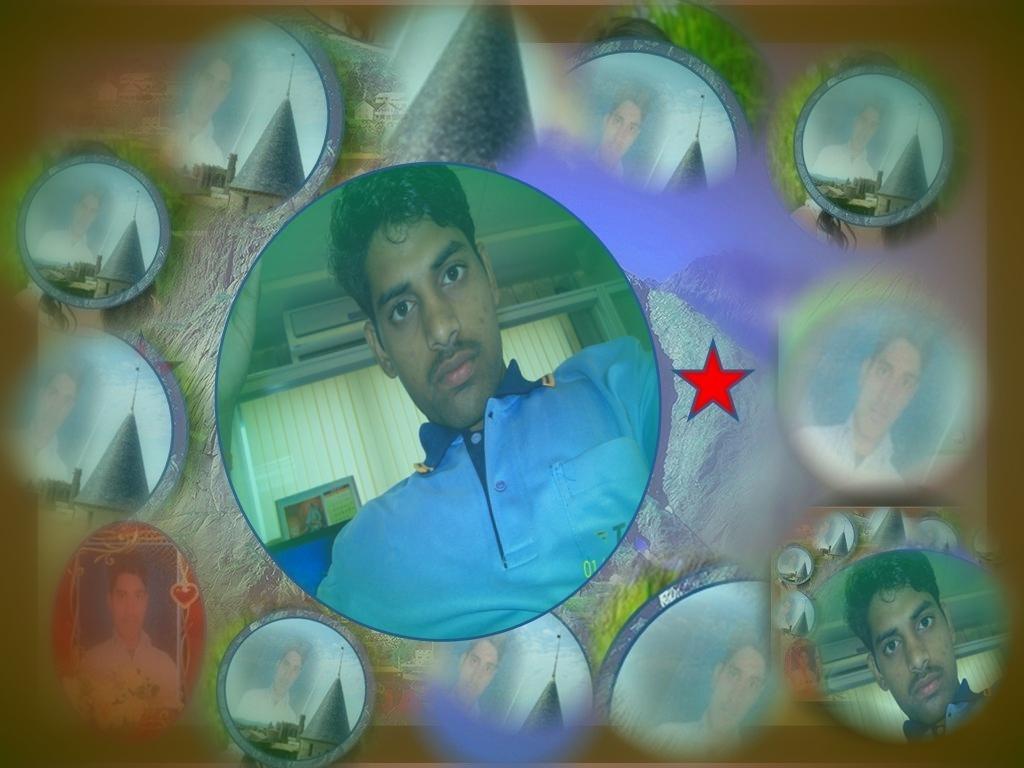Please provide a concise description of this image. This is a edited image as we can see there is one person in the middle of this image, and there are some other pictures of a person in the background. 